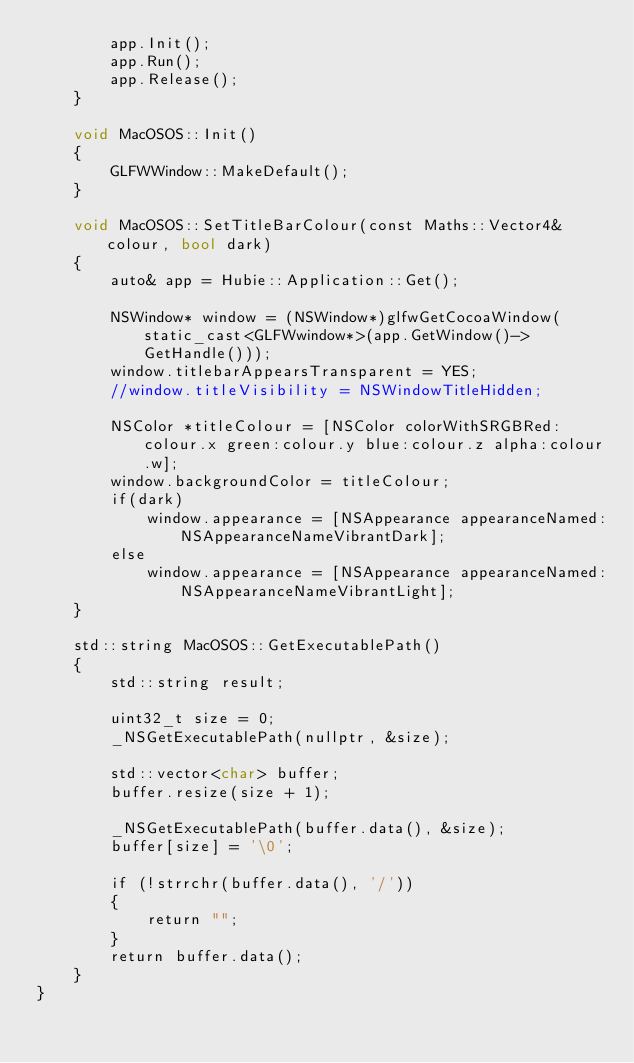Convert code to text. <code><loc_0><loc_0><loc_500><loc_500><_ObjectiveC_>        app.Init();
        app.Run();
        app.Release();
    }

    void MacOSOS::Init()
    {
        GLFWWindow::MakeDefault();
    }

    void MacOSOS::SetTitleBarColour(const Maths::Vector4& colour, bool dark)
    {
        auto& app = Hubie::Application::Get();

        NSWindow* window = (NSWindow*)glfwGetCocoaWindow(static_cast<GLFWwindow*>(app.GetWindow()->GetHandle()));
        window.titlebarAppearsTransparent = YES;
        //window.titleVisibility = NSWindowTitleHidden;
        
        NSColor *titleColour = [NSColor colorWithSRGBRed:colour.x green:colour.y blue:colour.z alpha:colour.w];
        window.backgroundColor = titleColour;
        if(dark)
            window.appearance = [NSAppearance appearanceNamed:NSAppearanceNameVibrantDark];
        else
            window.appearance = [NSAppearance appearanceNamed:NSAppearanceNameVibrantLight];
    }

    std::string MacOSOS::GetExecutablePath()
    {
        std::string result;

        uint32_t size = 0;
        _NSGetExecutablePath(nullptr, &size);

        std::vector<char> buffer;
        buffer.resize(size + 1);

        _NSGetExecutablePath(buffer.data(), &size);
        buffer[size] = '\0';

        if (!strrchr(buffer.data(), '/'))
        {
            return "";
        }
        return buffer.data();
    }
}
</code> 